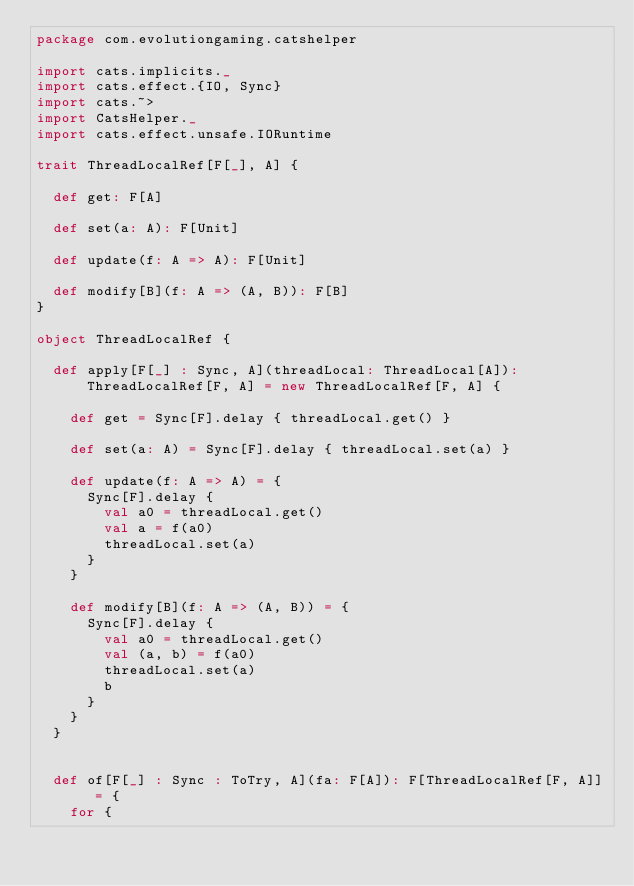<code> <loc_0><loc_0><loc_500><loc_500><_Scala_>package com.evolutiongaming.catshelper

import cats.implicits._
import cats.effect.{IO, Sync}
import cats.~>
import CatsHelper._
import cats.effect.unsafe.IORuntime

trait ThreadLocalRef[F[_], A] {

  def get: F[A]

  def set(a: A): F[Unit]

  def update(f: A => A): F[Unit]

  def modify[B](f: A => (A, B)): F[B]
}

object ThreadLocalRef {

  def apply[F[_] : Sync, A](threadLocal: ThreadLocal[A]): ThreadLocalRef[F, A] = new ThreadLocalRef[F, A] {

    def get = Sync[F].delay { threadLocal.get() }

    def set(a: A) = Sync[F].delay { threadLocal.set(a) }

    def update(f: A => A) = {
      Sync[F].delay {
        val a0 = threadLocal.get()
        val a = f(a0)
        threadLocal.set(a)
      }
    }

    def modify[B](f: A => (A, B)) = {
      Sync[F].delay {
        val a0 = threadLocal.get()
        val (a, b) = f(a0)
        threadLocal.set(a)
        b
      }
    }
  }


  def of[F[_] : Sync : ToTry, A](fa: F[A]): F[ThreadLocalRef[F, A]] = {
    for {</code> 